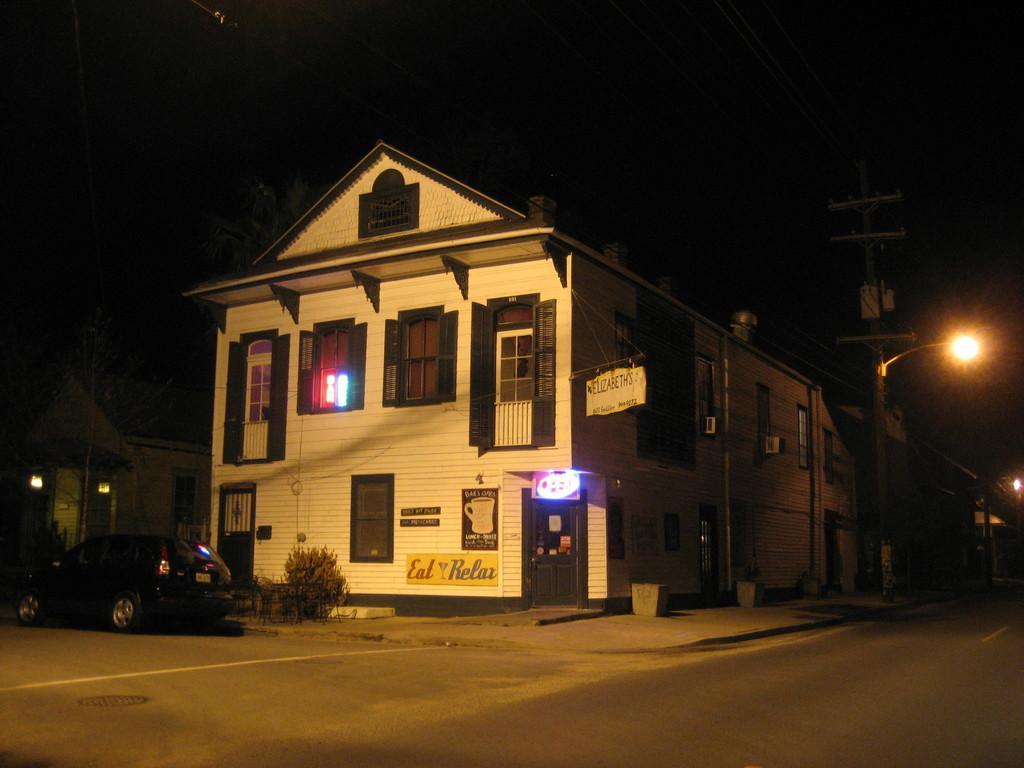How would you summarize this image in a sentence or two? This picture is clicked outside the city. In this picture, we see the road. On the left side, we see a car in black color is parked on the road. Behind that, we see a building in white color. In front of that, we see a shrub. On the right side, we see a street light. In the background, it is black in color and this picture is clicked in the dark. 